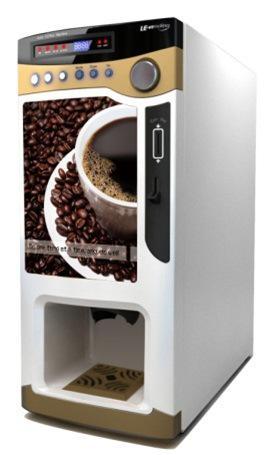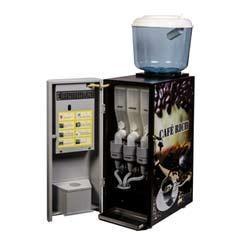The first image is the image on the left, the second image is the image on the right. Assess this claim about the two images: "In one image the coffee maker is open.". Correct or not? Answer yes or no. Yes. The first image is the image on the left, the second image is the image on the right. Given the left and right images, does the statement "Top right and bottom left is a duplicate." hold true? Answer yes or no. No. 